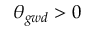Convert formula to latex. <formula><loc_0><loc_0><loc_500><loc_500>\theta _ { g w d } > 0</formula> 